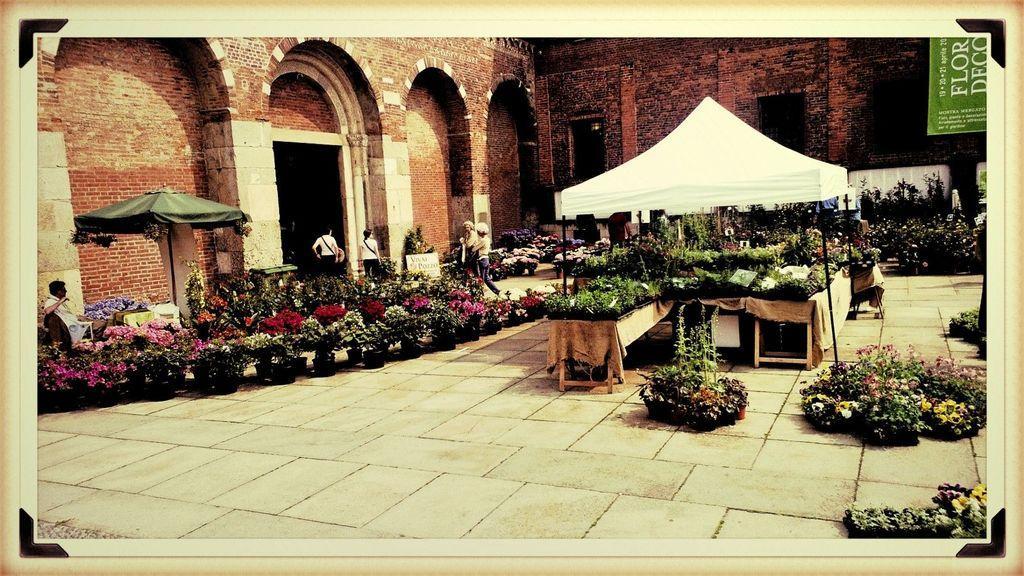In one or two sentences, can you explain what this image depicts? In this image I can see few tables, few sheds, few people and number of plants in pots. I can also see different types of flowers and on the top right side of this image I can see a green colour board and on it I can see something is written. 